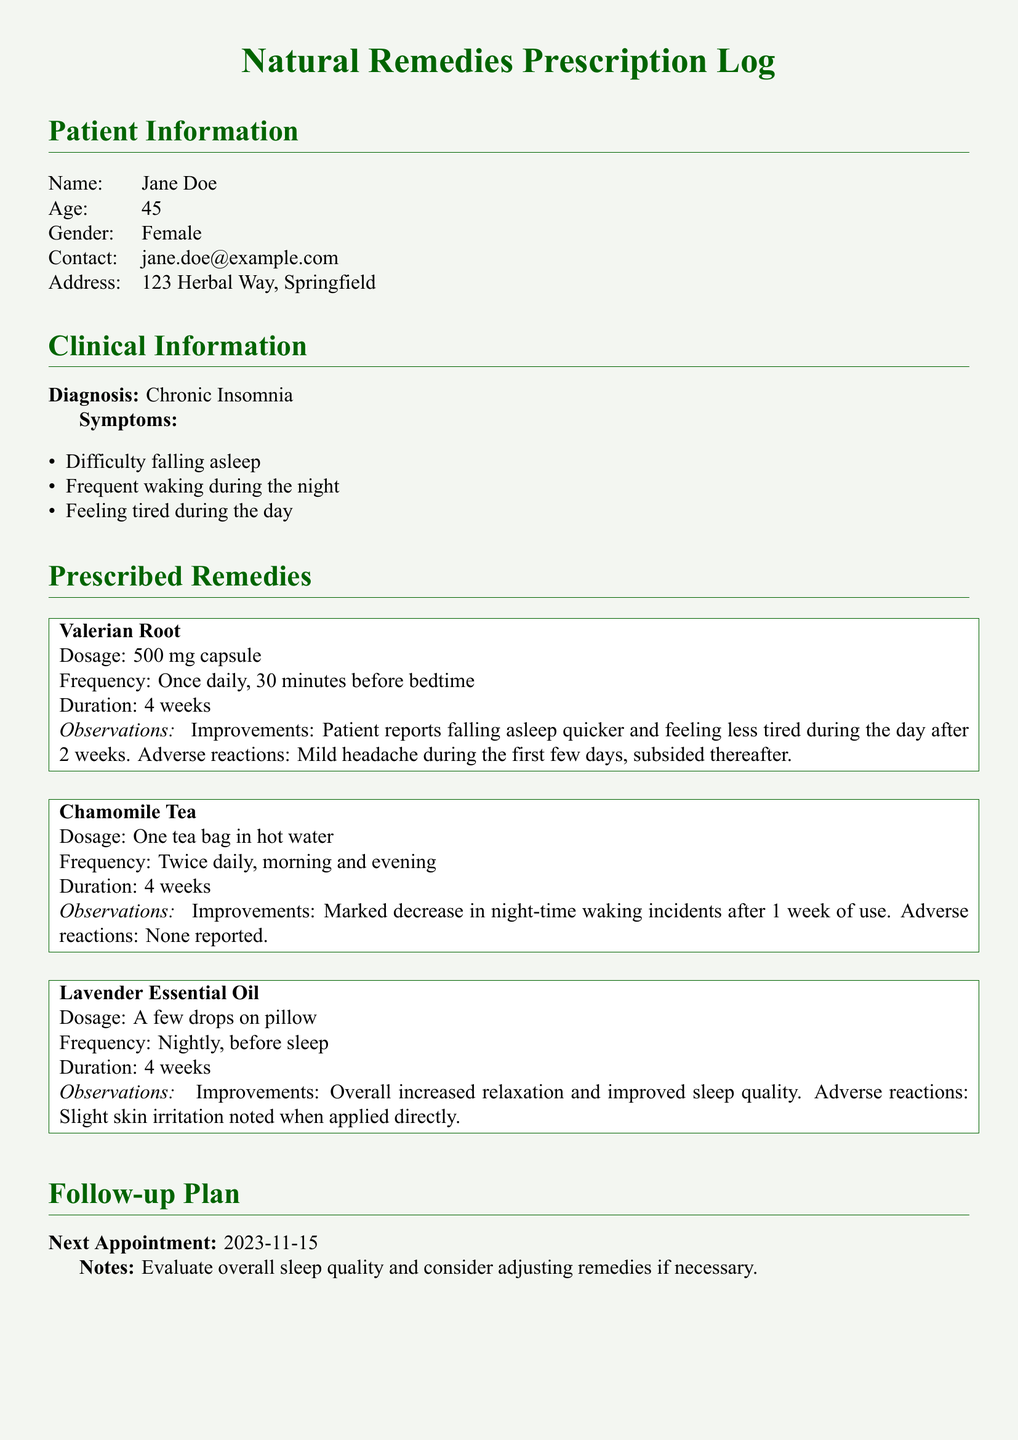What is the name of the patient? The patient's name is listed in the Patient Information section of the document.
Answer: Jane Doe What is the prescribed dosage of Valerian Root? The dosage for Valerian Root is specified in the Prescribed Remedies section under the remedy details.
Answer: 500 mg capsule How long should the patient take Chamomile Tea? The treatment duration for Chamomile Tea is mentioned next to the remedy.
Answer: 4 weeks What improvements were reported with the use of Lavender Essential Oil? The improvements for Lavender Essential Oil are detailed in the Observations section of the remedy box.
Answer: Overall increased relaxation and improved sleep quality What was the frequency of taking the Valerian Root? The frequency of Valerian Root is indicated in the Prescribed Remedies section with the remedy details.
Answer: Once daily, 30 minutes before bedtime What adverse reaction was noted for Valerian Root? The adverse reaction for Valerian Root is mentioned in the Observations section of the remedy box.
Answer: Mild headache during the first few days When is the patient's next appointment scheduled? The next appointment date is provided under the Follow-up Plan section of the document.
Answer: 2023-11-15 How many types of natural remedies are prescribed? The number of remedies can be counted from the Prescribed Remedies section where each remedy is listed.
Answer: 3 